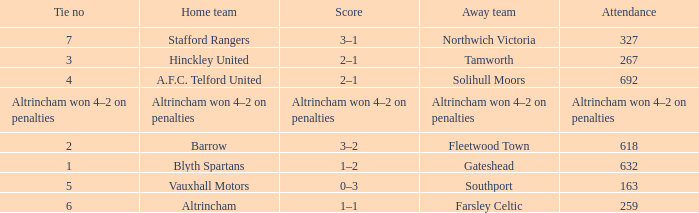What was the attendance for the away team Solihull Moors? 692.0. 